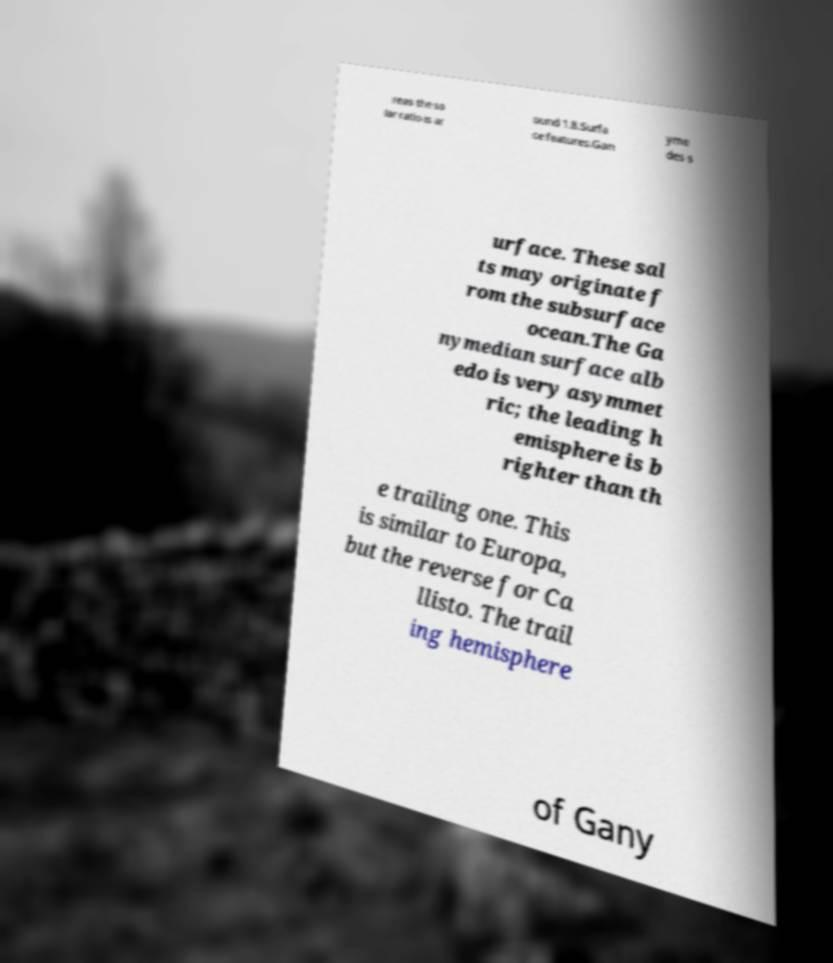Please identify and transcribe the text found in this image. reas the so lar ratio is ar ound 1.8.Surfa ce features.Gan yme des s urface. These sal ts may originate f rom the subsurface ocean.The Ga nymedian surface alb edo is very asymmet ric; the leading h emisphere is b righter than th e trailing one. This is similar to Europa, but the reverse for Ca llisto. The trail ing hemisphere of Gany 